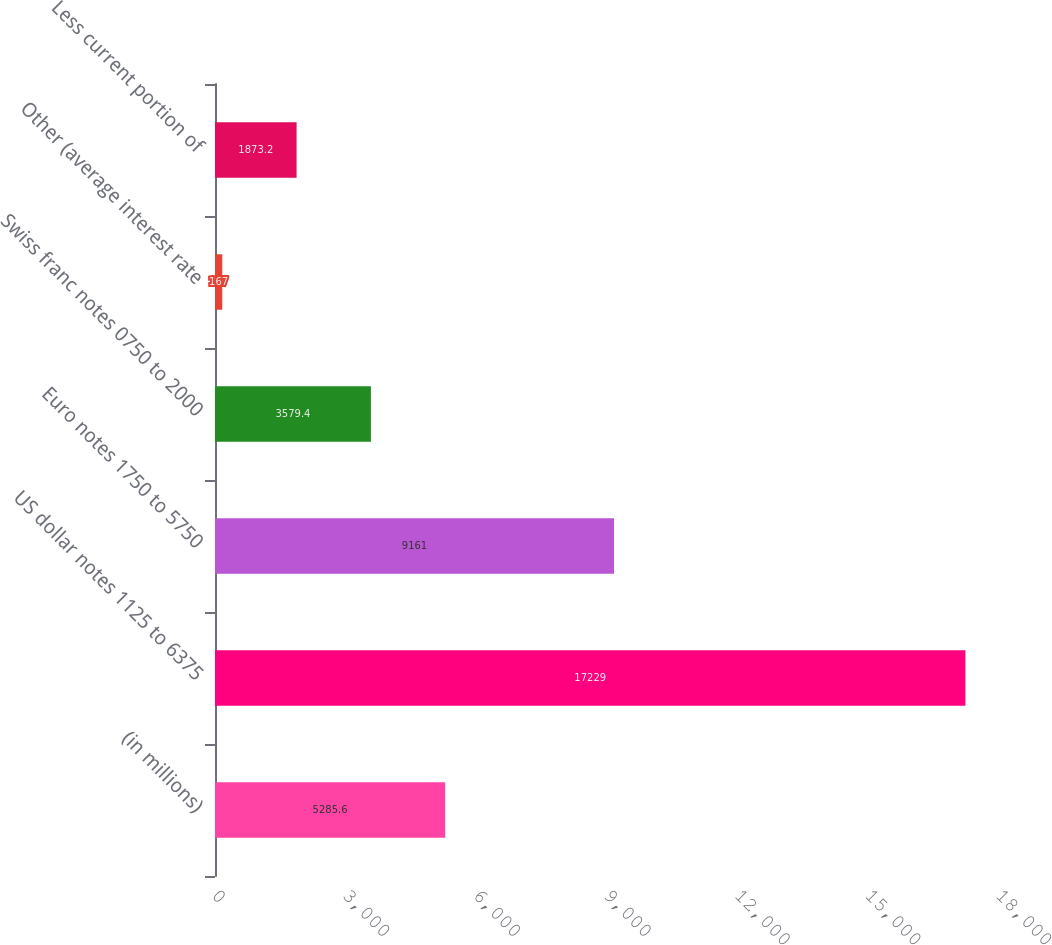<chart> <loc_0><loc_0><loc_500><loc_500><bar_chart><fcel>(in millions)<fcel>US dollar notes 1125 to 6375<fcel>Euro notes 1750 to 5750<fcel>Swiss franc notes 0750 to 2000<fcel>Other (average interest rate<fcel>Less current portion of<nl><fcel>5285.6<fcel>17229<fcel>9161<fcel>3579.4<fcel>167<fcel>1873.2<nl></chart> 